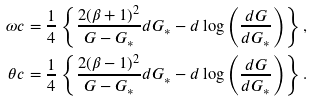Convert formula to latex. <formula><loc_0><loc_0><loc_500><loc_500>\omega c & = \frac { 1 } { 4 } \left \{ \frac { 2 ( \beta + 1 ) ^ { 2 } } { G - G _ { * } } d G _ { * } - d \log \left ( \frac { d G } { d G _ { * } } \right ) \right \} , \\ \theta c & = \frac { 1 } { 4 } \left \{ \frac { 2 ( \beta - 1 ) ^ { 2 } } { G - G _ { * } } d G _ { * } - d \log \left ( \frac { d G } { d G _ { * } } \right ) \right \} .</formula> 